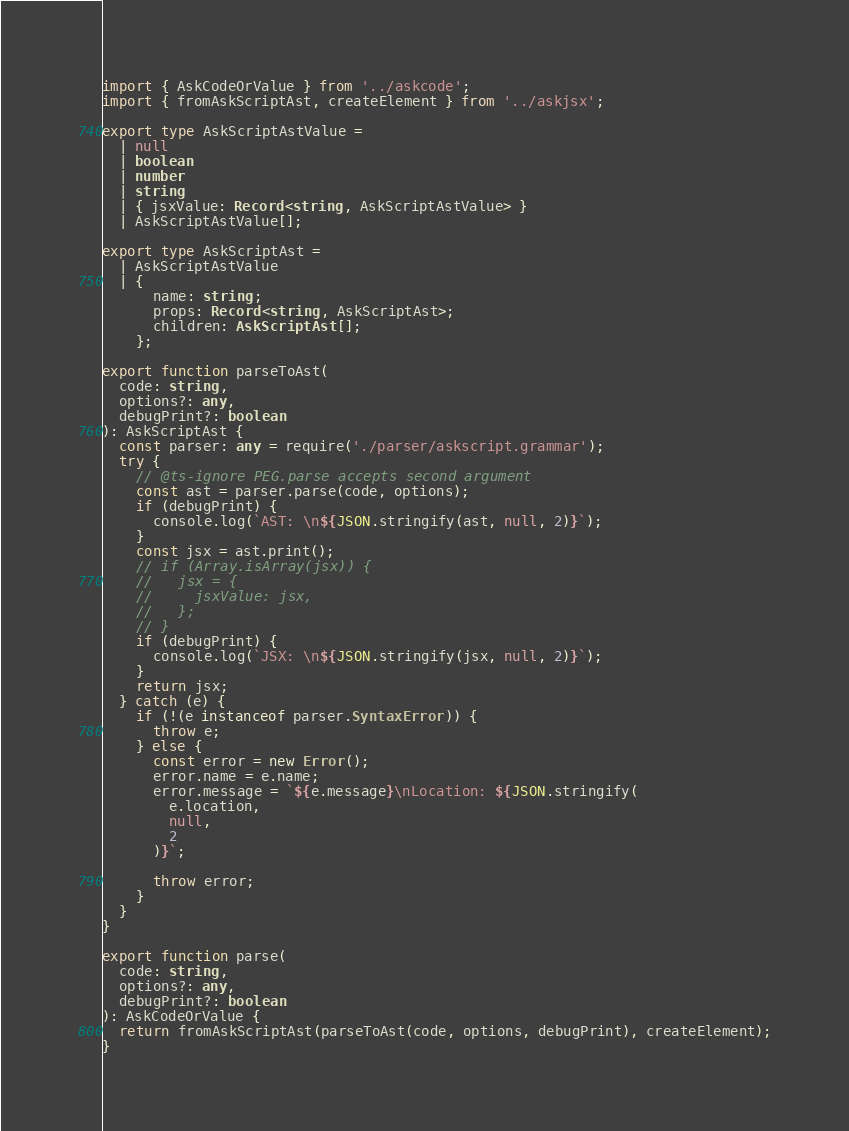<code> <loc_0><loc_0><loc_500><loc_500><_TypeScript_>import { AskCodeOrValue } from '../askcode';
import { fromAskScriptAst, createElement } from '../askjsx';

export type AskScriptAstValue =
  | null
  | boolean
  | number
  | string
  | { jsxValue: Record<string, AskScriptAstValue> }
  | AskScriptAstValue[];

export type AskScriptAst =
  | AskScriptAstValue
  | {
      name: string;
      props: Record<string, AskScriptAst>;
      children: AskScriptAst[];
    };

export function parseToAst(
  code: string,
  options?: any,
  debugPrint?: boolean
): AskScriptAst {
  const parser: any = require('./parser/askscript.grammar');
  try {
    // @ts-ignore PEG.parse accepts second argument
    const ast = parser.parse(code, options);
    if (debugPrint) {
      console.log(`AST: \n${JSON.stringify(ast, null, 2)}`);
    }
    const jsx = ast.print();
    // if (Array.isArray(jsx)) {
    //   jsx = {
    //     jsxValue: jsx,
    //   };
    // }
    if (debugPrint) {
      console.log(`JSX: \n${JSON.stringify(jsx, null, 2)}`);
    }
    return jsx;
  } catch (e) {
    if (!(e instanceof parser.SyntaxError)) {
      throw e;
    } else {
      const error = new Error();
      error.name = e.name;
      error.message = `${e.message}\nLocation: ${JSON.stringify(
        e.location,
        null,
        2
      )}`;

      throw error;
    }
  }
}

export function parse(
  code: string,
  options?: any,
  debugPrint?: boolean
): AskCodeOrValue {
  return fromAskScriptAst(parseToAst(code, options, debugPrint), createElement);
}
</code> 